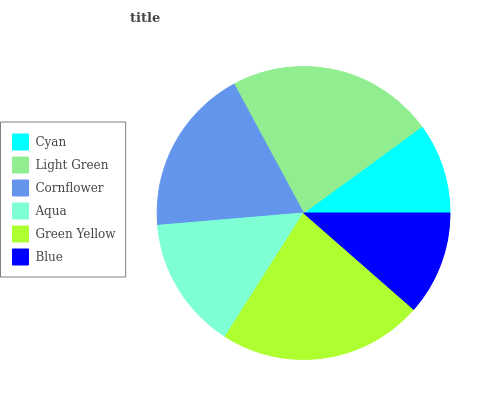Is Cyan the minimum?
Answer yes or no. Yes. Is Light Green the maximum?
Answer yes or no. Yes. Is Cornflower the minimum?
Answer yes or no. No. Is Cornflower the maximum?
Answer yes or no. No. Is Light Green greater than Cornflower?
Answer yes or no. Yes. Is Cornflower less than Light Green?
Answer yes or no. Yes. Is Cornflower greater than Light Green?
Answer yes or no. No. Is Light Green less than Cornflower?
Answer yes or no. No. Is Cornflower the high median?
Answer yes or no. Yes. Is Aqua the low median?
Answer yes or no. Yes. Is Aqua the high median?
Answer yes or no. No. Is Green Yellow the low median?
Answer yes or no. No. 